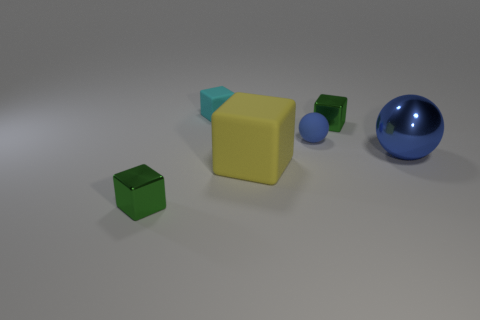Is there a pattern to how the objects are arranged? The objects are arranged with no discernible pattern, grouped towards the center of the image but with varying distances from one another, suggesting a random placement rather than a deliberate pattern. 